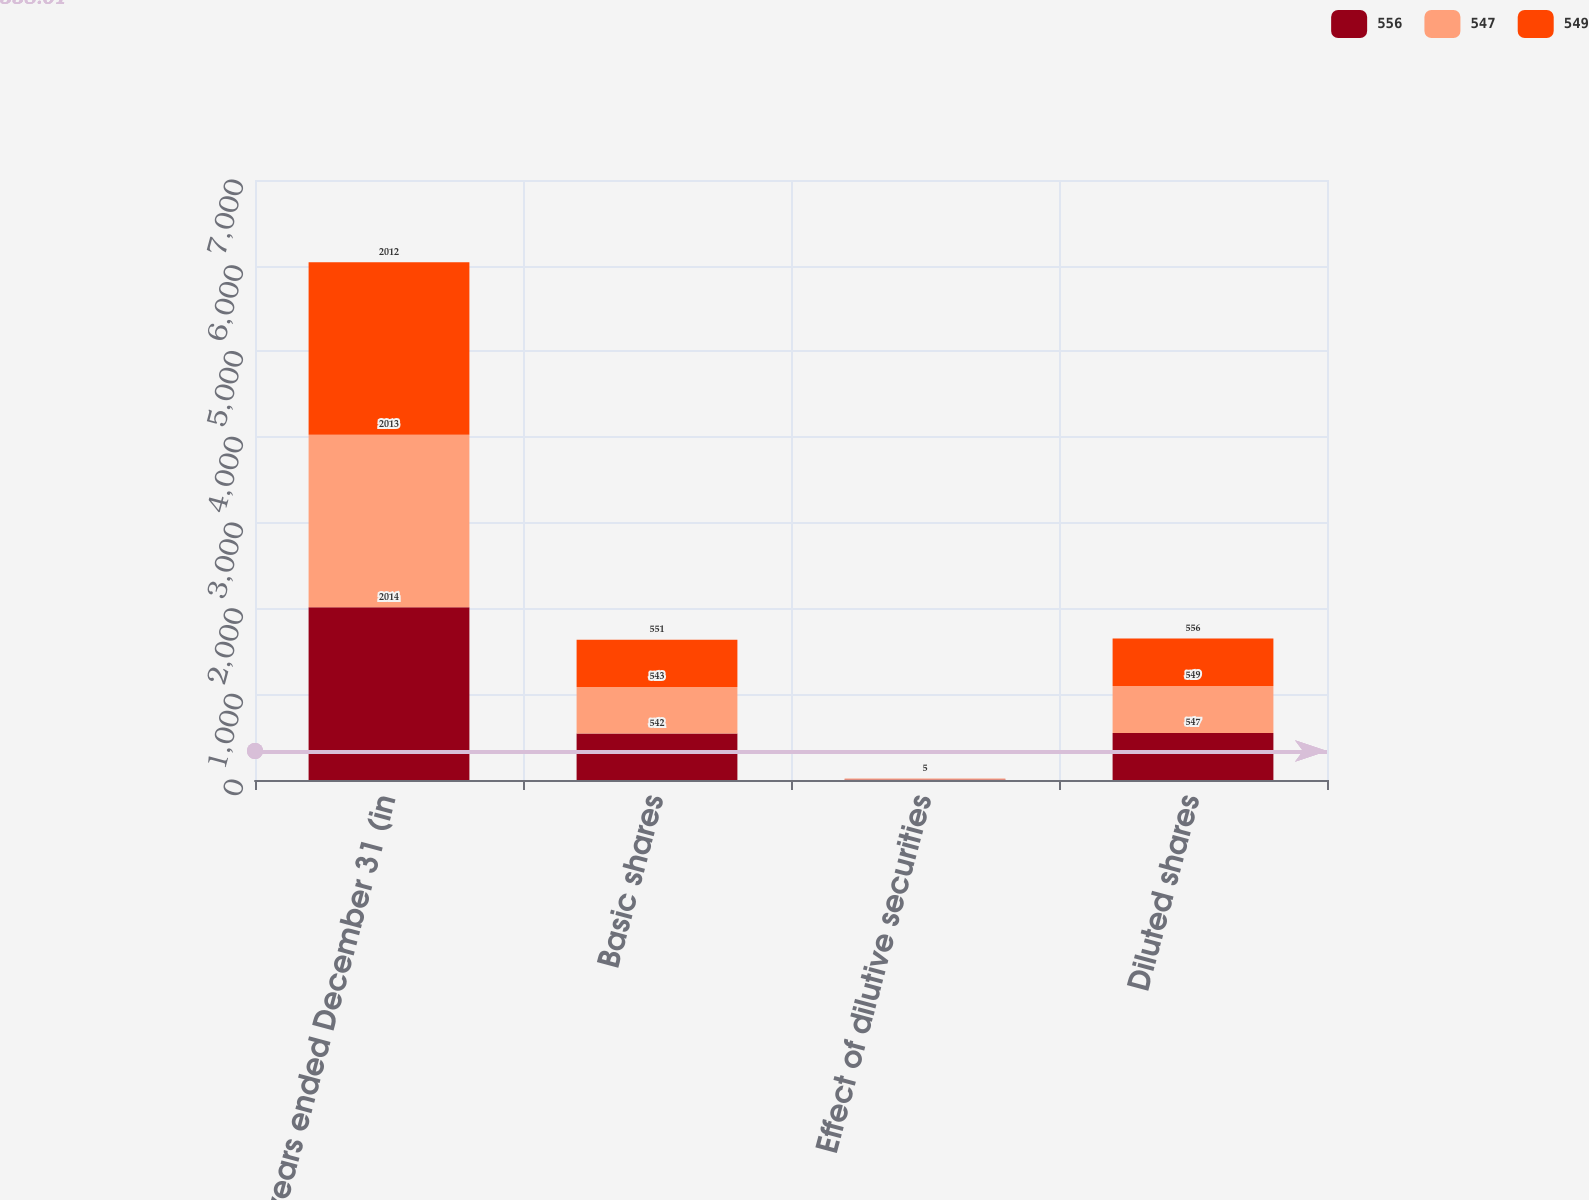<chart> <loc_0><loc_0><loc_500><loc_500><stacked_bar_chart><ecel><fcel>years ended December 31 (in<fcel>Basic shares<fcel>Effect of dilutive securities<fcel>Diluted shares<nl><fcel>556<fcel>2014<fcel>542<fcel>5<fcel>547<nl><fcel>547<fcel>2013<fcel>543<fcel>6<fcel>549<nl><fcel>549<fcel>2012<fcel>551<fcel>5<fcel>556<nl></chart> 